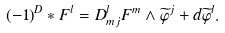<formula> <loc_0><loc_0><loc_500><loc_500>( - 1 ) ^ { D } \ast F ^ { l } = D _ { m j } ^ { l } F ^ { m } \wedge \widetilde { \varphi } ^ { j } + d \widetilde { \varphi } ^ { l } .</formula> 